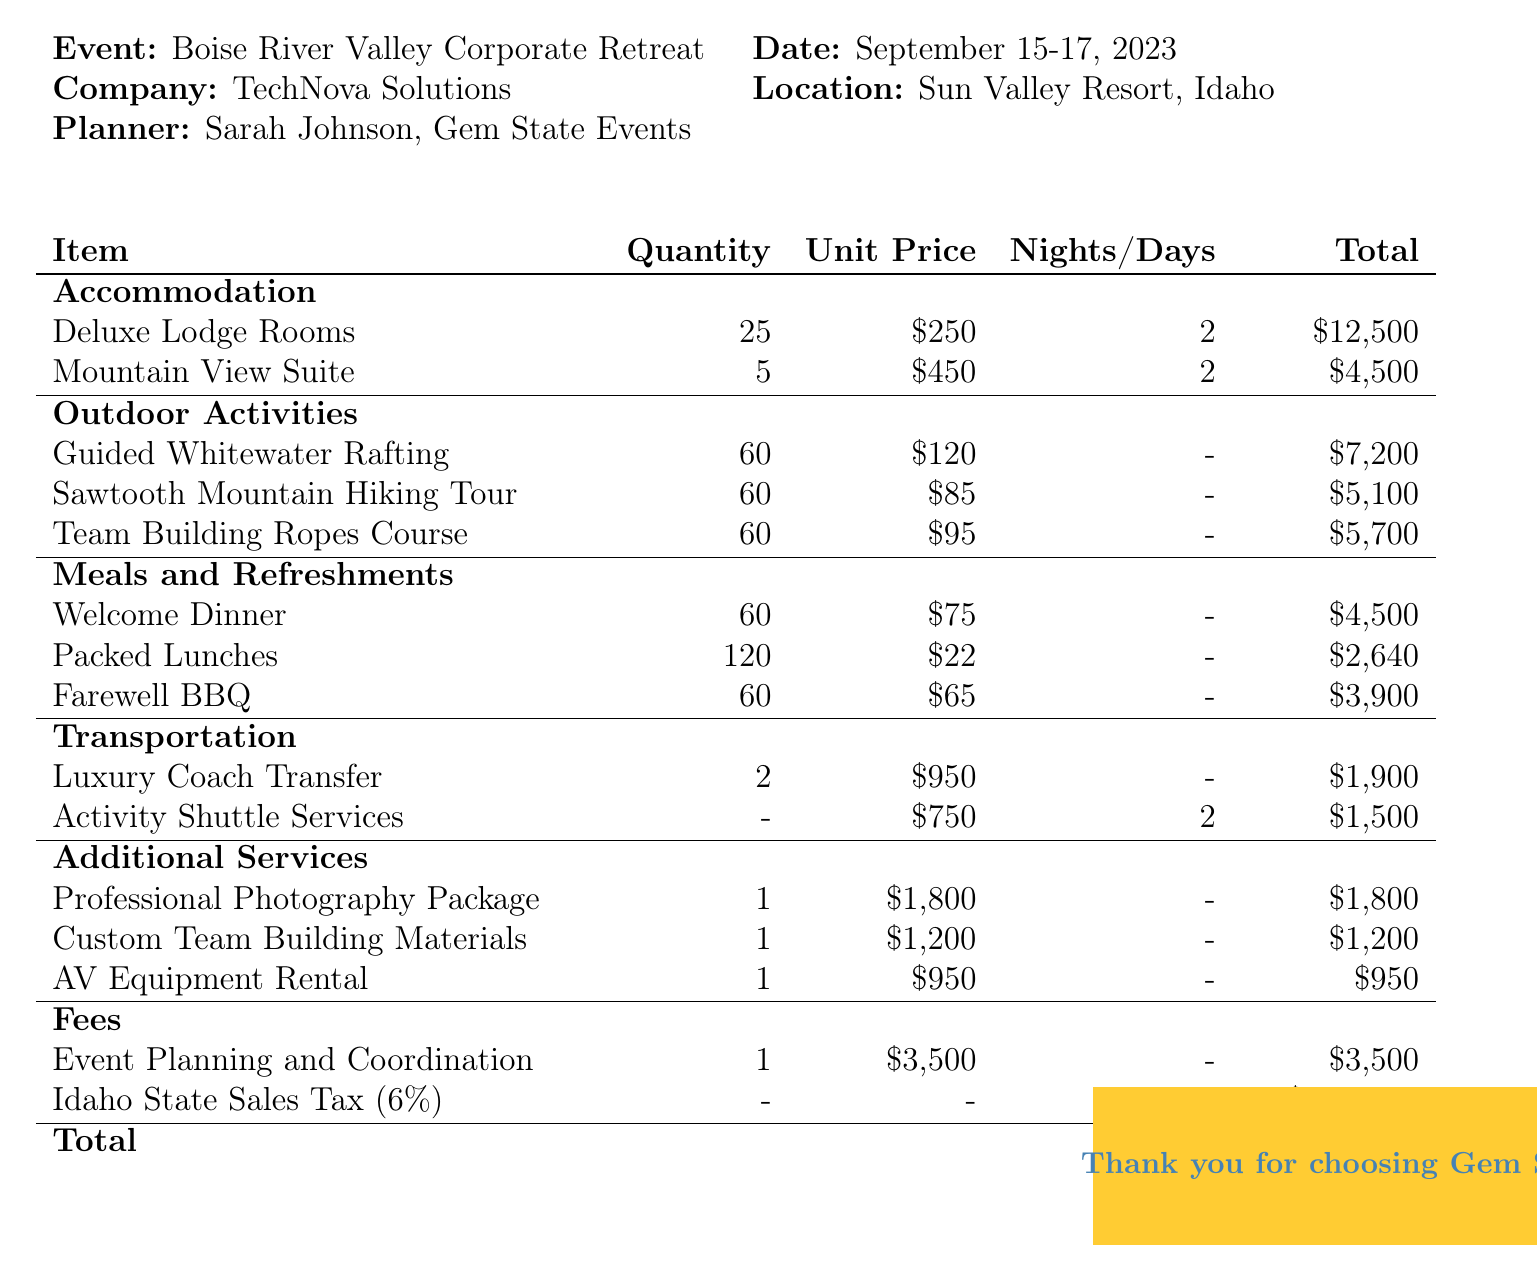What is the event name? The event name is specified at the beginning of the document.
Answer: Boise River Valley Corporate Retreat Who is the planner? The name of the planner is mentioned in the invoice details section.
Answer: Sarah Johnson, Gem State Events How many nights of accommodation were booked? The number of nights is provided for the accommodations listed in the document.
Answer: 2 What is the total cost for the Deluxe Lodge Rooms? The total cost is provided alongside the accommodation details.
Answer: $12500 How many participants were involved in the Guided Whitewater Rafting? The number of participants for the outdoor activity is specified in the activities section.
Answer: 60 What is the price per person for the Team Building Ropes Course? The price per person for outdoor activities is listed in the corresponding section of the document.
Answer: $95 What is the total amount for meals and refreshments? The total for meals involves the sums of all meal items listed in the document.
Answer: $11140 What is the total invoice amount? The total amount is provided at the end of the invoice summary.
Answer: $60303.40 What additional service costs $1200? The additional services section lists various services with their respective costs.
Answer: Custom Team Building Materials 